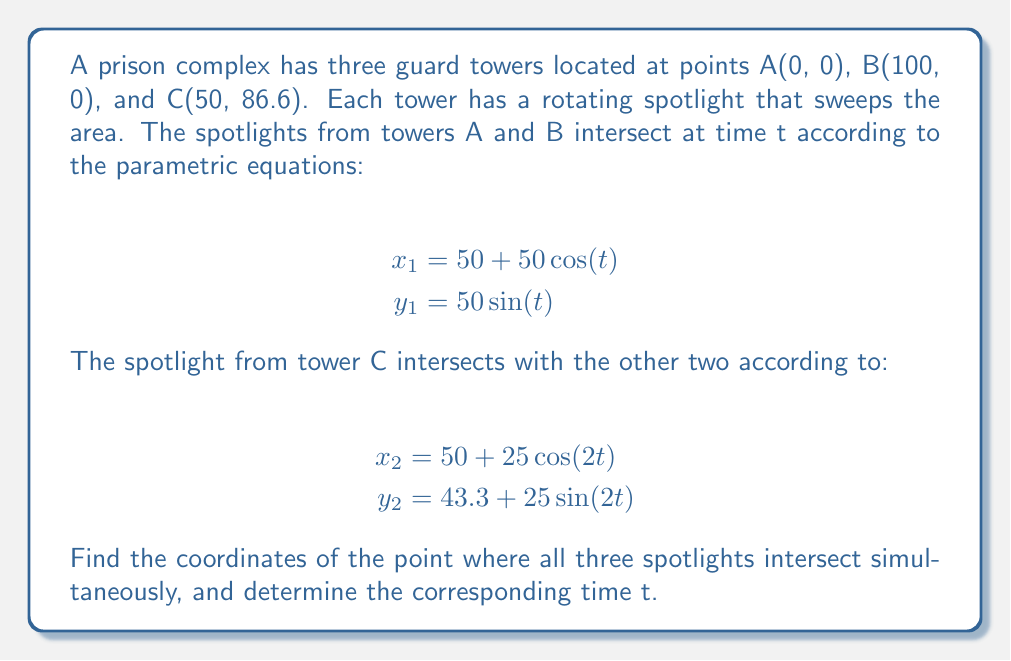What is the answer to this math problem? To solve this problem, we need to find the point and time where the two sets of parametric equations intersect. This will be the point where all three spotlights meet.

1) First, we set the x and y equations equal to each other:

   $$50 + 50\cos(t) = 50 + 25\cos(2t)$$
   $$50\sin(t) = 43.3 + 25\sin(2t)$$

2) From the first equation:
   $$50\cos(t) = 25\cos(2t)$$
   $$2\cos(t) = \cos(2t)$$

3) Using the double angle formula $\cos(2t) = 2\cos^2(t) - 1$, we get:
   $$2\cos(t) = 2\cos^2(t) - 1$$
   $$2\cos^2(t) - 2\cos(t) - 1 = 0$$

4) This is a quadratic in $\cos(t)$. Solving it:
   $$\cos(t) = \frac{2 \pm \sqrt{4 + 8}}{4} = \frac{2 \pm \sqrt{12}}{4} = \frac{1 \pm \sqrt{3}}{2}$$

5) The solution $\cos(t) = \frac{1 + \sqrt{3}}{2}$ corresponds to $t = \frac{\pi}{6}$ or $30°$.

6) We can verify this using the y-equation:
   $$50\sin(\frac{\pi}{6}) = 43.3 + 25\sin(\frac{\pi}{3})$$
   $$25 = 43.3 + 21.65$$
   $$25 \approx 25 \quad \text{(allowing for rounding errors)}$$

7) Now we can find the intersection point by plugging $t = \frac{\pi}{6}$ into either set of parametric equations:

   $$x = 50 + 50\cos(\frac{\pi}{6}) = 50 + 50(\frac{\sqrt{3}}{2}) = 50 + 25\sqrt{3} \approx 93.3$$
   $$y = 50\sin(\frac{\pi}{6}) = 25$$
Answer: The three spotlights intersect at the point $(50 + 25\sqrt{3}, 25)$, or approximately $(93.3, 25)$, at time $t = \frac{\pi}{6}$ radians or $30°$. 